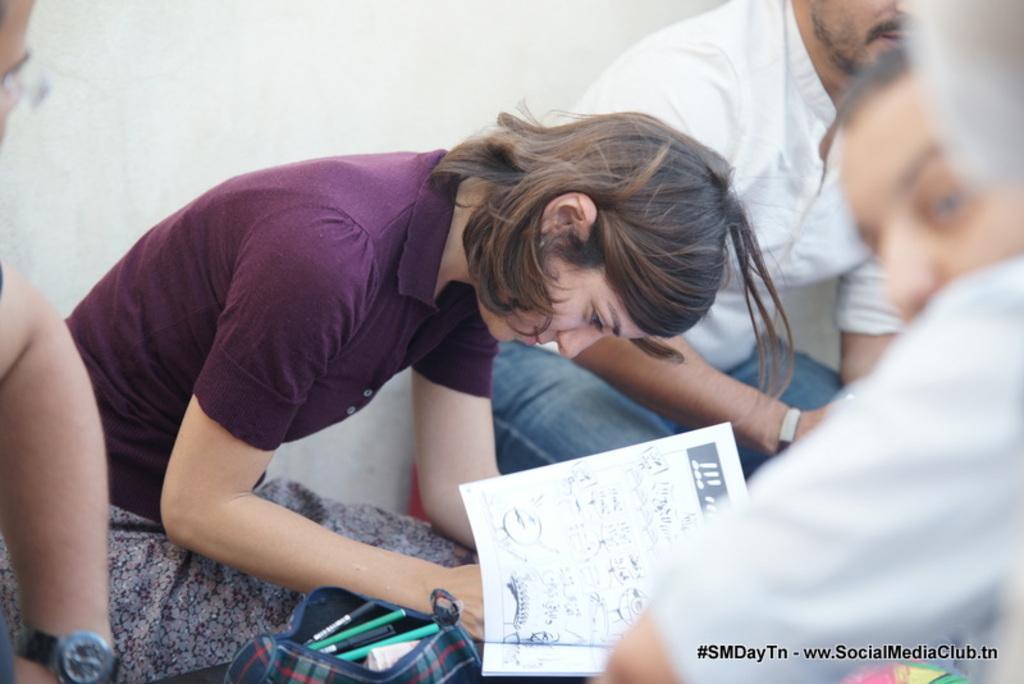In one or two sentences, can you explain what this image depicts? In this image there are some people sitting, in the center there is one woman who is holding some papers and it seems that she is writing. Beside her there is one bag, in the bag there are some pens and in the background there is wall. At the bottom of the image there is some text. 